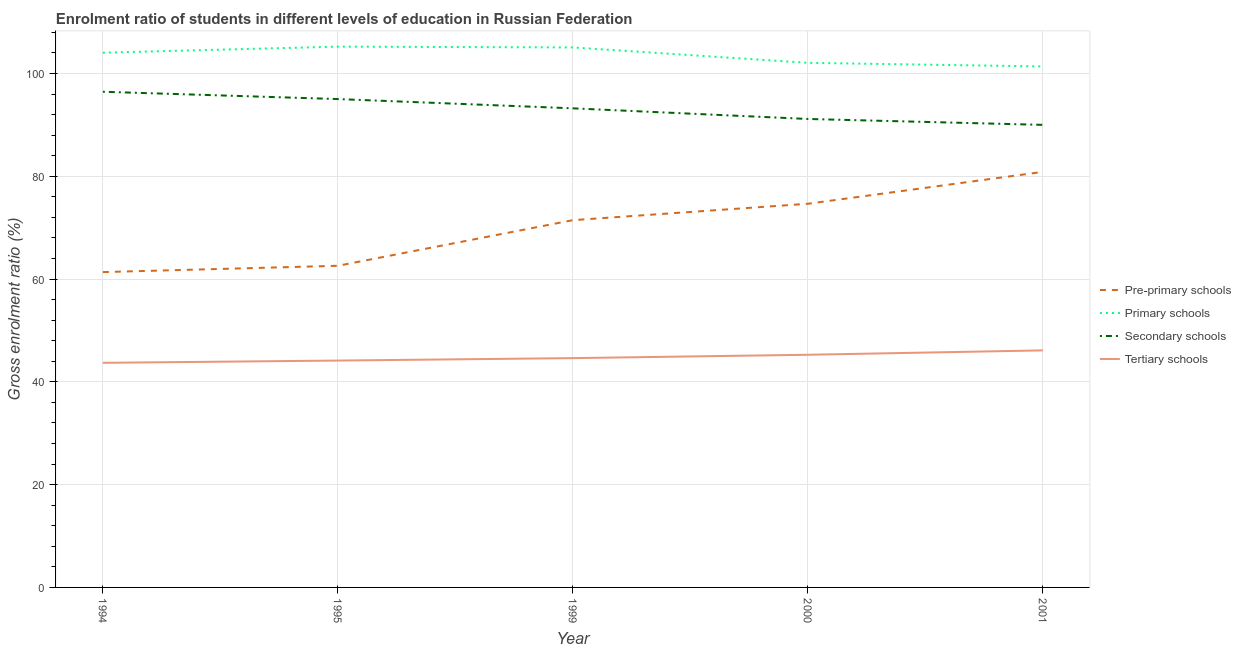Is the number of lines equal to the number of legend labels?
Provide a short and direct response. Yes. What is the gross enrolment ratio in secondary schools in 1994?
Offer a terse response. 96.45. Across all years, what is the maximum gross enrolment ratio in tertiary schools?
Your response must be concise. 46.13. Across all years, what is the minimum gross enrolment ratio in secondary schools?
Ensure brevity in your answer.  90.01. In which year was the gross enrolment ratio in tertiary schools maximum?
Your answer should be very brief. 2001. In which year was the gross enrolment ratio in primary schools minimum?
Provide a short and direct response. 2001. What is the total gross enrolment ratio in tertiary schools in the graph?
Make the answer very short. 223.87. What is the difference between the gross enrolment ratio in primary schools in 1995 and that in 1999?
Your response must be concise. 0.16. What is the difference between the gross enrolment ratio in tertiary schools in 1999 and the gross enrolment ratio in pre-primary schools in 1994?
Provide a succinct answer. -16.74. What is the average gross enrolment ratio in pre-primary schools per year?
Make the answer very short. 70.19. In the year 1999, what is the difference between the gross enrolment ratio in pre-primary schools and gross enrolment ratio in primary schools?
Your response must be concise. -33.61. What is the ratio of the gross enrolment ratio in pre-primary schools in 1995 to that in 2001?
Your answer should be very brief. 0.77. Is the gross enrolment ratio in tertiary schools in 1999 less than that in 2000?
Provide a short and direct response. Yes. Is the difference between the gross enrolment ratio in tertiary schools in 1995 and 1999 greater than the difference between the gross enrolment ratio in pre-primary schools in 1995 and 1999?
Keep it short and to the point. Yes. What is the difference between the highest and the second highest gross enrolment ratio in tertiary schools?
Provide a short and direct response. 0.86. What is the difference between the highest and the lowest gross enrolment ratio in primary schools?
Your answer should be very brief. 3.86. Is the sum of the gross enrolment ratio in tertiary schools in 1994 and 2001 greater than the maximum gross enrolment ratio in primary schools across all years?
Your response must be concise. No. Is it the case that in every year, the sum of the gross enrolment ratio in tertiary schools and gross enrolment ratio in pre-primary schools is greater than the sum of gross enrolment ratio in primary schools and gross enrolment ratio in secondary schools?
Ensure brevity in your answer.  No. Does the gross enrolment ratio in tertiary schools monotonically increase over the years?
Make the answer very short. Yes. Is the gross enrolment ratio in primary schools strictly greater than the gross enrolment ratio in tertiary schools over the years?
Provide a short and direct response. Yes. Is the gross enrolment ratio in pre-primary schools strictly less than the gross enrolment ratio in tertiary schools over the years?
Give a very brief answer. No. How many years are there in the graph?
Offer a very short reply. 5. What is the difference between two consecutive major ticks on the Y-axis?
Make the answer very short. 20. What is the title of the graph?
Your response must be concise. Enrolment ratio of students in different levels of education in Russian Federation. What is the label or title of the Y-axis?
Give a very brief answer. Gross enrolment ratio (%). What is the Gross enrolment ratio (%) in Pre-primary schools in 1994?
Offer a very short reply. 61.36. What is the Gross enrolment ratio (%) in Primary schools in 1994?
Ensure brevity in your answer.  104.05. What is the Gross enrolment ratio (%) of Secondary schools in 1994?
Ensure brevity in your answer.  96.45. What is the Gross enrolment ratio (%) in Tertiary schools in 1994?
Your answer should be compact. 43.7. What is the Gross enrolment ratio (%) of Pre-primary schools in 1995?
Offer a very short reply. 62.59. What is the Gross enrolment ratio (%) in Primary schools in 1995?
Provide a short and direct response. 105.23. What is the Gross enrolment ratio (%) in Secondary schools in 1995?
Provide a short and direct response. 95.03. What is the Gross enrolment ratio (%) in Tertiary schools in 1995?
Provide a succinct answer. 44.15. What is the Gross enrolment ratio (%) of Pre-primary schools in 1999?
Give a very brief answer. 71.46. What is the Gross enrolment ratio (%) in Primary schools in 1999?
Keep it short and to the point. 105.07. What is the Gross enrolment ratio (%) of Secondary schools in 1999?
Your response must be concise. 93.23. What is the Gross enrolment ratio (%) of Tertiary schools in 1999?
Your answer should be compact. 44.62. What is the Gross enrolment ratio (%) in Pre-primary schools in 2000?
Provide a succinct answer. 74.66. What is the Gross enrolment ratio (%) of Primary schools in 2000?
Your answer should be very brief. 102.08. What is the Gross enrolment ratio (%) in Secondary schools in 2000?
Provide a short and direct response. 91.15. What is the Gross enrolment ratio (%) of Tertiary schools in 2000?
Your answer should be compact. 45.27. What is the Gross enrolment ratio (%) of Pre-primary schools in 2001?
Offer a very short reply. 80.86. What is the Gross enrolment ratio (%) of Primary schools in 2001?
Offer a very short reply. 101.37. What is the Gross enrolment ratio (%) of Secondary schools in 2001?
Your answer should be compact. 90.01. What is the Gross enrolment ratio (%) of Tertiary schools in 2001?
Keep it short and to the point. 46.13. Across all years, what is the maximum Gross enrolment ratio (%) in Pre-primary schools?
Make the answer very short. 80.86. Across all years, what is the maximum Gross enrolment ratio (%) of Primary schools?
Provide a short and direct response. 105.23. Across all years, what is the maximum Gross enrolment ratio (%) in Secondary schools?
Provide a short and direct response. 96.45. Across all years, what is the maximum Gross enrolment ratio (%) in Tertiary schools?
Your answer should be very brief. 46.13. Across all years, what is the minimum Gross enrolment ratio (%) of Pre-primary schools?
Your answer should be compact. 61.36. Across all years, what is the minimum Gross enrolment ratio (%) in Primary schools?
Your answer should be very brief. 101.37. Across all years, what is the minimum Gross enrolment ratio (%) in Secondary schools?
Ensure brevity in your answer.  90.01. Across all years, what is the minimum Gross enrolment ratio (%) of Tertiary schools?
Provide a short and direct response. 43.7. What is the total Gross enrolment ratio (%) of Pre-primary schools in the graph?
Ensure brevity in your answer.  350.93. What is the total Gross enrolment ratio (%) of Primary schools in the graph?
Keep it short and to the point. 517.81. What is the total Gross enrolment ratio (%) of Secondary schools in the graph?
Your answer should be very brief. 465.87. What is the total Gross enrolment ratio (%) of Tertiary schools in the graph?
Your answer should be very brief. 223.87. What is the difference between the Gross enrolment ratio (%) of Pre-primary schools in 1994 and that in 1995?
Ensure brevity in your answer.  -1.23. What is the difference between the Gross enrolment ratio (%) in Primary schools in 1994 and that in 1995?
Offer a terse response. -1.18. What is the difference between the Gross enrolment ratio (%) of Secondary schools in 1994 and that in 1995?
Provide a succinct answer. 1.42. What is the difference between the Gross enrolment ratio (%) of Tertiary schools in 1994 and that in 1995?
Give a very brief answer. -0.44. What is the difference between the Gross enrolment ratio (%) of Pre-primary schools in 1994 and that in 1999?
Make the answer very short. -10.1. What is the difference between the Gross enrolment ratio (%) of Primary schools in 1994 and that in 1999?
Keep it short and to the point. -1.02. What is the difference between the Gross enrolment ratio (%) in Secondary schools in 1994 and that in 1999?
Your answer should be very brief. 3.23. What is the difference between the Gross enrolment ratio (%) of Tertiary schools in 1994 and that in 1999?
Offer a terse response. -0.92. What is the difference between the Gross enrolment ratio (%) in Pre-primary schools in 1994 and that in 2000?
Provide a succinct answer. -13.3. What is the difference between the Gross enrolment ratio (%) of Primary schools in 1994 and that in 2000?
Ensure brevity in your answer.  1.97. What is the difference between the Gross enrolment ratio (%) in Secondary schools in 1994 and that in 2000?
Your response must be concise. 5.3. What is the difference between the Gross enrolment ratio (%) in Tertiary schools in 1994 and that in 2000?
Your answer should be very brief. -1.57. What is the difference between the Gross enrolment ratio (%) of Pre-primary schools in 1994 and that in 2001?
Your answer should be very brief. -19.5. What is the difference between the Gross enrolment ratio (%) of Primary schools in 1994 and that in 2001?
Ensure brevity in your answer.  2.68. What is the difference between the Gross enrolment ratio (%) of Secondary schools in 1994 and that in 2001?
Provide a succinct answer. 6.44. What is the difference between the Gross enrolment ratio (%) of Tertiary schools in 1994 and that in 2001?
Provide a short and direct response. -2.42. What is the difference between the Gross enrolment ratio (%) of Pre-primary schools in 1995 and that in 1999?
Provide a short and direct response. -8.88. What is the difference between the Gross enrolment ratio (%) of Primary schools in 1995 and that in 1999?
Give a very brief answer. 0.16. What is the difference between the Gross enrolment ratio (%) of Secondary schools in 1995 and that in 1999?
Provide a short and direct response. 1.8. What is the difference between the Gross enrolment ratio (%) of Tertiary schools in 1995 and that in 1999?
Provide a short and direct response. -0.47. What is the difference between the Gross enrolment ratio (%) of Pre-primary schools in 1995 and that in 2000?
Your answer should be compact. -12.07. What is the difference between the Gross enrolment ratio (%) in Primary schools in 1995 and that in 2000?
Give a very brief answer. 3.15. What is the difference between the Gross enrolment ratio (%) in Secondary schools in 1995 and that in 2000?
Give a very brief answer. 3.87. What is the difference between the Gross enrolment ratio (%) of Tertiary schools in 1995 and that in 2000?
Your answer should be very brief. -1.13. What is the difference between the Gross enrolment ratio (%) of Pre-primary schools in 1995 and that in 2001?
Provide a short and direct response. -18.28. What is the difference between the Gross enrolment ratio (%) in Primary schools in 1995 and that in 2001?
Provide a short and direct response. 3.86. What is the difference between the Gross enrolment ratio (%) in Secondary schools in 1995 and that in 2001?
Make the answer very short. 5.02. What is the difference between the Gross enrolment ratio (%) of Tertiary schools in 1995 and that in 2001?
Give a very brief answer. -1.98. What is the difference between the Gross enrolment ratio (%) in Pre-primary schools in 1999 and that in 2000?
Provide a short and direct response. -3.19. What is the difference between the Gross enrolment ratio (%) in Primary schools in 1999 and that in 2000?
Offer a terse response. 3. What is the difference between the Gross enrolment ratio (%) in Secondary schools in 1999 and that in 2000?
Your answer should be very brief. 2.07. What is the difference between the Gross enrolment ratio (%) in Tertiary schools in 1999 and that in 2000?
Ensure brevity in your answer.  -0.65. What is the difference between the Gross enrolment ratio (%) in Pre-primary schools in 1999 and that in 2001?
Ensure brevity in your answer.  -9.4. What is the difference between the Gross enrolment ratio (%) in Primary schools in 1999 and that in 2001?
Offer a terse response. 3.7. What is the difference between the Gross enrolment ratio (%) in Secondary schools in 1999 and that in 2001?
Make the answer very short. 3.22. What is the difference between the Gross enrolment ratio (%) of Tertiary schools in 1999 and that in 2001?
Your answer should be compact. -1.51. What is the difference between the Gross enrolment ratio (%) in Pre-primary schools in 2000 and that in 2001?
Provide a succinct answer. -6.21. What is the difference between the Gross enrolment ratio (%) of Primary schools in 2000 and that in 2001?
Your answer should be compact. 0.7. What is the difference between the Gross enrolment ratio (%) of Secondary schools in 2000 and that in 2001?
Your answer should be very brief. 1.15. What is the difference between the Gross enrolment ratio (%) in Tertiary schools in 2000 and that in 2001?
Make the answer very short. -0.86. What is the difference between the Gross enrolment ratio (%) in Pre-primary schools in 1994 and the Gross enrolment ratio (%) in Primary schools in 1995?
Ensure brevity in your answer.  -43.87. What is the difference between the Gross enrolment ratio (%) of Pre-primary schools in 1994 and the Gross enrolment ratio (%) of Secondary schools in 1995?
Offer a terse response. -33.67. What is the difference between the Gross enrolment ratio (%) in Pre-primary schools in 1994 and the Gross enrolment ratio (%) in Tertiary schools in 1995?
Your response must be concise. 17.21. What is the difference between the Gross enrolment ratio (%) of Primary schools in 1994 and the Gross enrolment ratio (%) of Secondary schools in 1995?
Make the answer very short. 9.02. What is the difference between the Gross enrolment ratio (%) in Primary schools in 1994 and the Gross enrolment ratio (%) in Tertiary schools in 1995?
Offer a terse response. 59.91. What is the difference between the Gross enrolment ratio (%) of Secondary schools in 1994 and the Gross enrolment ratio (%) of Tertiary schools in 1995?
Your response must be concise. 52.31. What is the difference between the Gross enrolment ratio (%) in Pre-primary schools in 1994 and the Gross enrolment ratio (%) in Primary schools in 1999?
Make the answer very short. -43.72. What is the difference between the Gross enrolment ratio (%) of Pre-primary schools in 1994 and the Gross enrolment ratio (%) of Secondary schools in 1999?
Give a very brief answer. -31.87. What is the difference between the Gross enrolment ratio (%) in Pre-primary schools in 1994 and the Gross enrolment ratio (%) in Tertiary schools in 1999?
Ensure brevity in your answer.  16.74. What is the difference between the Gross enrolment ratio (%) of Primary schools in 1994 and the Gross enrolment ratio (%) of Secondary schools in 1999?
Provide a short and direct response. 10.82. What is the difference between the Gross enrolment ratio (%) in Primary schools in 1994 and the Gross enrolment ratio (%) in Tertiary schools in 1999?
Provide a succinct answer. 59.43. What is the difference between the Gross enrolment ratio (%) of Secondary schools in 1994 and the Gross enrolment ratio (%) of Tertiary schools in 1999?
Offer a very short reply. 51.83. What is the difference between the Gross enrolment ratio (%) of Pre-primary schools in 1994 and the Gross enrolment ratio (%) of Primary schools in 2000?
Ensure brevity in your answer.  -40.72. What is the difference between the Gross enrolment ratio (%) in Pre-primary schools in 1994 and the Gross enrolment ratio (%) in Secondary schools in 2000?
Your answer should be compact. -29.8. What is the difference between the Gross enrolment ratio (%) of Pre-primary schools in 1994 and the Gross enrolment ratio (%) of Tertiary schools in 2000?
Provide a succinct answer. 16.09. What is the difference between the Gross enrolment ratio (%) in Primary schools in 1994 and the Gross enrolment ratio (%) in Secondary schools in 2000?
Give a very brief answer. 12.9. What is the difference between the Gross enrolment ratio (%) in Primary schools in 1994 and the Gross enrolment ratio (%) in Tertiary schools in 2000?
Offer a terse response. 58.78. What is the difference between the Gross enrolment ratio (%) of Secondary schools in 1994 and the Gross enrolment ratio (%) of Tertiary schools in 2000?
Your answer should be very brief. 51.18. What is the difference between the Gross enrolment ratio (%) of Pre-primary schools in 1994 and the Gross enrolment ratio (%) of Primary schools in 2001?
Offer a terse response. -40.02. What is the difference between the Gross enrolment ratio (%) in Pre-primary schools in 1994 and the Gross enrolment ratio (%) in Secondary schools in 2001?
Your response must be concise. -28.65. What is the difference between the Gross enrolment ratio (%) in Pre-primary schools in 1994 and the Gross enrolment ratio (%) in Tertiary schools in 2001?
Your answer should be very brief. 15.23. What is the difference between the Gross enrolment ratio (%) in Primary schools in 1994 and the Gross enrolment ratio (%) in Secondary schools in 2001?
Your answer should be compact. 14.04. What is the difference between the Gross enrolment ratio (%) in Primary schools in 1994 and the Gross enrolment ratio (%) in Tertiary schools in 2001?
Offer a terse response. 57.92. What is the difference between the Gross enrolment ratio (%) of Secondary schools in 1994 and the Gross enrolment ratio (%) of Tertiary schools in 2001?
Keep it short and to the point. 50.32. What is the difference between the Gross enrolment ratio (%) of Pre-primary schools in 1995 and the Gross enrolment ratio (%) of Primary schools in 1999?
Your answer should be compact. -42.49. What is the difference between the Gross enrolment ratio (%) in Pre-primary schools in 1995 and the Gross enrolment ratio (%) in Secondary schools in 1999?
Make the answer very short. -30.64. What is the difference between the Gross enrolment ratio (%) in Pre-primary schools in 1995 and the Gross enrolment ratio (%) in Tertiary schools in 1999?
Your response must be concise. 17.97. What is the difference between the Gross enrolment ratio (%) in Primary schools in 1995 and the Gross enrolment ratio (%) in Secondary schools in 1999?
Offer a terse response. 12. What is the difference between the Gross enrolment ratio (%) in Primary schools in 1995 and the Gross enrolment ratio (%) in Tertiary schools in 1999?
Offer a terse response. 60.61. What is the difference between the Gross enrolment ratio (%) in Secondary schools in 1995 and the Gross enrolment ratio (%) in Tertiary schools in 1999?
Your answer should be compact. 50.41. What is the difference between the Gross enrolment ratio (%) of Pre-primary schools in 1995 and the Gross enrolment ratio (%) of Primary schools in 2000?
Make the answer very short. -39.49. What is the difference between the Gross enrolment ratio (%) in Pre-primary schools in 1995 and the Gross enrolment ratio (%) in Secondary schools in 2000?
Offer a very short reply. -28.57. What is the difference between the Gross enrolment ratio (%) in Pre-primary schools in 1995 and the Gross enrolment ratio (%) in Tertiary schools in 2000?
Your answer should be compact. 17.32. What is the difference between the Gross enrolment ratio (%) of Primary schools in 1995 and the Gross enrolment ratio (%) of Secondary schools in 2000?
Your answer should be compact. 14.08. What is the difference between the Gross enrolment ratio (%) in Primary schools in 1995 and the Gross enrolment ratio (%) in Tertiary schools in 2000?
Make the answer very short. 59.96. What is the difference between the Gross enrolment ratio (%) in Secondary schools in 1995 and the Gross enrolment ratio (%) in Tertiary schools in 2000?
Offer a terse response. 49.76. What is the difference between the Gross enrolment ratio (%) of Pre-primary schools in 1995 and the Gross enrolment ratio (%) of Primary schools in 2001?
Your response must be concise. -38.79. What is the difference between the Gross enrolment ratio (%) of Pre-primary schools in 1995 and the Gross enrolment ratio (%) of Secondary schools in 2001?
Offer a very short reply. -27.42. What is the difference between the Gross enrolment ratio (%) in Pre-primary schools in 1995 and the Gross enrolment ratio (%) in Tertiary schools in 2001?
Make the answer very short. 16.46. What is the difference between the Gross enrolment ratio (%) in Primary schools in 1995 and the Gross enrolment ratio (%) in Secondary schools in 2001?
Offer a very short reply. 15.22. What is the difference between the Gross enrolment ratio (%) of Primary schools in 1995 and the Gross enrolment ratio (%) of Tertiary schools in 2001?
Your answer should be compact. 59.1. What is the difference between the Gross enrolment ratio (%) of Secondary schools in 1995 and the Gross enrolment ratio (%) of Tertiary schools in 2001?
Provide a short and direct response. 48.9. What is the difference between the Gross enrolment ratio (%) of Pre-primary schools in 1999 and the Gross enrolment ratio (%) of Primary schools in 2000?
Your response must be concise. -30.61. What is the difference between the Gross enrolment ratio (%) of Pre-primary schools in 1999 and the Gross enrolment ratio (%) of Secondary schools in 2000?
Make the answer very short. -19.69. What is the difference between the Gross enrolment ratio (%) in Pre-primary schools in 1999 and the Gross enrolment ratio (%) in Tertiary schools in 2000?
Provide a short and direct response. 26.19. What is the difference between the Gross enrolment ratio (%) of Primary schools in 1999 and the Gross enrolment ratio (%) of Secondary schools in 2000?
Your response must be concise. 13.92. What is the difference between the Gross enrolment ratio (%) of Primary schools in 1999 and the Gross enrolment ratio (%) of Tertiary schools in 2000?
Provide a short and direct response. 59.8. What is the difference between the Gross enrolment ratio (%) of Secondary schools in 1999 and the Gross enrolment ratio (%) of Tertiary schools in 2000?
Offer a terse response. 47.95. What is the difference between the Gross enrolment ratio (%) in Pre-primary schools in 1999 and the Gross enrolment ratio (%) in Primary schools in 2001?
Provide a succinct answer. -29.91. What is the difference between the Gross enrolment ratio (%) in Pre-primary schools in 1999 and the Gross enrolment ratio (%) in Secondary schools in 2001?
Your answer should be very brief. -18.54. What is the difference between the Gross enrolment ratio (%) in Pre-primary schools in 1999 and the Gross enrolment ratio (%) in Tertiary schools in 2001?
Offer a terse response. 25.34. What is the difference between the Gross enrolment ratio (%) of Primary schools in 1999 and the Gross enrolment ratio (%) of Secondary schools in 2001?
Your response must be concise. 15.07. What is the difference between the Gross enrolment ratio (%) in Primary schools in 1999 and the Gross enrolment ratio (%) in Tertiary schools in 2001?
Give a very brief answer. 58.95. What is the difference between the Gross enrolment ratio (%) in Secondary schools in 1999 and the Gross enrolment ratio (%) in Tertiary schools in 2001?
Keep it short and to the point. 47.1. What is the difference between the Gross enrolment ratio (%) in Pre-primary schools in 2000 and the Gross enrolment ratio (%) in Primary schools in 2001?
Your answer should be very brief. -26.72. What is the difference between the Gross enrolment ratio (%) of Pre-primary schools in 2000 and the Gross enrolment ratio (%) of Secondary schools in 2001?
Provide a short and direct response. -15.35. What is the difference between the Gross enrolment ratio (%) of Pre-primary schools in 2000 and the Gross enrolment ratio (%) of Tertiary schools in 2001?
Your response must be concise. 28.53. What is the difference between the Gross enrolment ratio (%) in Primary schools in 2000 and the Gross enrolment ratio (%) in Secondary schools in 2001?
Keep it short and to the point. 12.07. What is the difference between the Gross enrolment ratio (%) in Primary schools in 2000 and the Gross enrolment ratio (%) in Tertiary schools in 2001?
Provide a succinct answer. 55.95. What is the difference between the Gross enrolment ratio (%) in Secondary schools in 2000 and the Gross enrolment ratio (%) in Tertiary schools in 2001?
Your response must be concise. 45.03. What is the average Gross enrolment ratio (%) in Pre-primary schools per year?
Your answer should be compact. 70.19. What is the average Gross enrolment ratio (%) of Primary schools per year?
Offer a very short reply. 103.56. What is the average Gross enrolment ratio (%) in Secondary schools per year?
Offer a very short reply. 93.17. What is the average Gross enrolment ratio (%) in Tertiary schools per year?
Keep it short and to the point. 44.77. In the year 1994, what is the difference between the Gross enrolment ratio (%) of Pre-primary schools and Gross enrolment ratio (%) of Primary schools?
Offer a very short reply. -42.69. In the year 1994, what is the difference between the Gross enrolment ratio (%) in Pre-primary schools and Gross enrolment ratio (%) in Secondary schools?
Provide a short and direct response. -35.09. In the year 1994, what is the difference between the Gross enrolment ratio (%) of Pre-primary schools and Gross enrolment ratio (%) of Tertiary schools?
Your answer should be compact. 17.66. In the year 1994, what is the difference between the Gross enrolment ratio (%) of Primary schools and Gross enrolment ratio (%) of Secondary schools?
Offer a very short reply. 7.6. In the year 1994, what is the difference between the Gross enrolment ratio (%) in Primary schools and Gross enrolment ratio (%) in Tertiary schools?
Keep it short and to the point. 60.35. In the year 1994, what is the difference between the Gross enrolment ratio (%) of Secondary schools and Gross enrolment ratio (%) of Tertiary schools?
Your answer should be compact. 52.75. In the year 1995, what is the difference between the Gross enrolment ratio (%) in Pre-primary schools and Gross enrolment ratio (%) in Primary schools?
Your response must be concise. -42.64. In the year 1995, what is the difference between the Gross enrolment ratio (%) of Pre-primary schools and Gross enrolment ratio (%) of Secondary schools?
Your answer should be compact. -32.44. In the year 1995, what is the difference between the Gross enrolment ratio (%) of Pre-primary schools and Gross enrolment ratio (%) of Tertiary schools?
Your answer should be compact. 18.44. In the year 1995, what is the difference between the Gross enrolment ratio (%) of Primary schools and Gross enrolment ratio (%) of Secondary schools?
Your answer should be compact. 10.2. In the year 1995, what is the difference between the Gross enrolment ratio (%) in Primary schools and Gross enrolment ratio (%) in Tertiary schools?
Ensure brevity in your answer.  61.09. In the year 1995, what is the difference between the Gross enrolment ratio (%) of Secondary schools and Gross enrolment ratio (%) of Tertiary schools?
Offer a terse response. 50.88. In the year 1999, what is the difference between the Gross enrolment ratio (%) of Pre-primary schools and Gross enrolment ratio (%) of Primary schools?
Keep it short and to the point. -33.61. In the year 1999, what is the difference between the Gross enrolment ratio (%) in Pre-primary schools and Gross enrolment ratio (%) in Secondary schools?
Offer a terse response. -21.76. In the year 1999, what is the difference between the Gross enrolment ratio (%) in Pre-primary schools and Gross enrolment ratio (%) in Tertiary schools?
Offer a very short reply. 26.84. In the year 1999, what is the difference between the Gross enrolment ratio (%) in Primary schools and Gross enrolment ratio (%) in Secondary schools?
Your answer should be very brief. 11.85. In the year 1999, what is the difference between the Gross enrolment ratio (%) in Primary schools and Gross enrolment ratio (%) in Tertiary schools?
Ensure brevity in your answer.  60.45. In the year 1999, what is the difference between the Gross enrolment ratio (%) in Secondary schools and Gross enrolment ratio (%) in Tertiary schools?
Keep it short and to the point. 48.61. In the year 2000, what is the difference between the Gross enrolment ratio (%) in Pre-primary schools and Gross enrolment ratio (%) in Primary schools?
Provide a succinct answer. -27.42. In the year 2000, what is the difference between the Gross enrolment ratio (%) of Pre-primary schools and Gross enrolment ratio (%) of Secondary schools?
Your answer should be very brief. -16.5. In the year 2000, what is the difference between the Gross enrolment ratio (%) in Pre-primary schools and Gross enrolment ratio (%) in Tertiary schools?
Offer a very short reply. 29.39. In the year 2000, what is the difference between the Gross enrolment ratio (%) in Primary schools and Gross enrolment ratio (%) in Secondary schools?
Offer a very short reply. 10.92. In the year 2000, what is the difference between the Gross enrolment ratio (%) of Primary schools and Gross enrolment ratio (%) of Tertiary schools?
Give a very brief answer. 56.81. In the year 2000, what is the difference between the Gross enrolment ratio (%) of Secondary schools and Gross enrolment ratio (%) of Tertiary schools?
Provide a short and direct response. 45.88. In the year 2001, what is the difference between the Gross enrolment ratio (%) in Pre-primary schools and Gross enrolment ratio (%) in Primary schools?
Ensure brevity in your answer.  -20.51. In the year 2001, what is the difference between the Gross enrolment ratio (%) in Pre-primary schools and Gross enrolment ratio (%) in Secondary schools?
Your response must be concise. -9.14. In the year 2001, what is the difference between the Gross enrolment ratio (%) in Pre-primary schools and Gross enrolment ratio (%) in Tertiary schools?
Your answer should be very brief. 34.74. In the year 2001, what is the difference between the Gross enrolment ratio (%) of Primary schools and Gross enrolment ratio (%) of Secondary schools?
Provide a succinct answer. 11.37. In the year 2001, what is the difference between the Gross enrolment ratio (%) of Primary schools and Gross enrolment ratio (%) of Tertiary schools?
Your answer should be compact. 55.25. In the year 2001, what is the difference between the Gross enrolment ratio (%) in Secondary schools and Gross enrolment ratio (%) in Tertiary schools?
Your response must be concise. 43.88. What is the ratio of the Gross enrolment ratio (%) in Pre-primary schools in 1994 to that in 1995?
Make the answer very short. 0.98. What is the ratio of the Gross enrolment ratio (%) of Primary schools in 1994 to that in 1995?
Give a very brief answer. 0.99. What is the ratio of the Gross enrolment ratio (%) in Secondary schools in 1994 to that in 1995?
Provide a succinct answer. 1.01. What is the ratio of the Gross enrolment ratio (%) of Pre-primary schools in 1994 to that in 1999?
Ensure brevity in your answer.  0.86. What is the ratio of the Gross enrolment ratio (%) in Primary schools in 1994 to that in 1999?
Ensure brevity in your answer.  0.99. What is the ratio of the Gross enrolment ratio (%) in Secondary schools in 1994 to that in 1999?
Offer a very short reply. 1.03. What is the ratio of the Gross enrolment ratio (%) of Tertiary schools in 1994 to that in 1999?
Keep it short and to the point. 0.98. What is the ratio of the Gross enrolment ratio (%) in Pre-primary schools in 1994 to that in 2000?
Offer a very short reply. 0.82. What is the ratio of the Gross enrolment ratio (%) in Primary schools in 1994 to that in 2000?
Offer a very short reply. 1.02. What is the ratio of the Gross enrolment ratio (%) in Secondary schools in 1994 to that in 2000?
Make the answer very short. 1.06. What is the ratio of the Gross enrolment ratio (%) of Tertiary schools in 1994 to that in 2000?
Offer a very short reply. 0.97. What is the ratio of the Gross enrolment ratio (%) in Pre-primary schools in 1994 to that in 2001?
Give a very brief answer. 0.76. What is the ratio of the Gross enrolment ratio (%) in Primary schools in 1994 to that in 2001?
Give a very brief answer. 1.03. What is the ratio of the Gross enrolment ratio (%) of Secondary schools in 1994 to that in 2001?
Your answer should be compact. 1.07. What is the ratio of the Gross enrolment ratio (%) of Tertiary schools in 1994 to that in 2001?
Make the answer very short. 0.95. What is the ratio of the Gross enrolment ratio (%) in Pre-primary schools in 1995 to that in 1999?
Provide a succinct answer. 0.88. What is the ratio of the Gross enrolment ratio (%) in Primary schools in 1995 to that in 1999?
Keep it short and to the point. 1. What is the ratio of the Gross enrolment ratio (%) of Secondary schools in 1995 to that in 1999?
Your answer should be very brief. 1.02. What is the ratio of the Gross enrolment ratio (%) of Pre-primary schools in 1995 to that in 2000?
Provide a succinct answer. 0.84. What is the ratio of the Gross enrolment ratio (%) in Primary schools in 1995 to that in 2000?
Provide a short and direct response. 1.03. What is the ratio of the Gross enrolment ratio (%) of Secondary schools in 1995 to that in 2000?
Provide a short and direct response. 1.04. What is the ratio of the Gross enrolment ratio (%) of Tertiary schools in 1995 to that in 2000?
Offer a terse response. 0.98. What is the ratio of the Gross enrolment ratio (%) in Pre-primary schools in 1995 to that in 2001?
Make the answer very short. 0.77. What is the ratio of the Gross enrolment ratio (%) in Primary schools in 1995 to that in 2001?
Keep it short and to the point. 1.04. What is the ratio of the Gross enrolment ratio (%) in Secondary schools in 1995 to that in 2001?
Offer a terse response. 1.06. What is the ratio of the Gross enrolment ratio (%) in Tertiary schools in 1995 to that in 2001?
Provide a succinct answer. 0.96. What is the ratio of the Gross enrolment ratio (%) in Pre-primary schools in 1999 to that in 2000?
Ensure brevity in your answer.  0.96. What is the ratio of the Gross enrolment ratio (%) in Primary schools in 1999 to that in 2000?
Give a very brief answer. 1.03. What is the ratio of the Gross enrolment ratio (%) in Secondary schools in 1999 to that in 2000?
Your answer should be very brief. 1.02. What is the ratio of the Gross enrolment ratio (%) in Tertiary schools in 1999 to that in 2000?
Ensure brevity in your answer.  0.99. What is the ratio of the Gross enrolment ratio (%) in Pre-primary schools in 1999 to that in 2001?
Give a very brief answer. 0.88. What is the ratio of the Gross enrolment ratio (%) of Primary schools in 1999 to that in 2001?
Give a very brief answer. 1.04. What is the ratio of the Gross enrolment ratio (%) in Secondary schools in 1999 to that in 2001?
Provide a short and direct response. 1.04. What is the ratio of the Gross enrolment ratio (%) of Tertiary schools in 1999 to that in 2001?
Ensure brevity in your answer.  0.97. What is the ratio of the Gross enrolment ratio (%) in Pre-primary schools in 2000 to that in 2001?
Provide a short and direct response. 0.92. What is the ratio of the Gross enrolment ratio (%) of Primary schools in 2000 to that in 2001?
Make the answer very short. 1.01. What is the ratio of the Gross enrolment ratio (%) of Secondary schools in 2000 to that in 2001?
Give a very brief answer. 1.01. What is the ratio of the Gross enrolment ratio (%) of Tertiary schools in 2000 to that in 2001?
Your answer should be compact. 0.98. What is the difference between the highest and the second highest Gross enrolment ratio (%) in Pre-primary schools?
Your answer should be compact. 6.21. What is the difference between the highest and the second highest Gross enrolment ratio (%) of Primary schools?
Give a very brief answer. 0.16. What is the difference between the highest and the second highest Gross enrolment ratio (%) in Secondary schools?
Make the answer very short. 1.42. What is the difference between the highest and the second highest Gross enrolment ratio (%) in Tertiary schools?
Give a very brief answer. 0.86. What is the difference between the highest and the lowest Gross enrolment ratio (%) of Pre-primary schools?
Your response must be concise. 19.5. What is the difference between the highest and the lowest Gross enrolment ratio (%) in Primary schools?
Provide a short and direct response. 3.86. What is the difference between the highest and the lowest Gross enrolment ratio (%) in Secondary schools?
Keep it short and to the point. 6.44. What is the difference between the highest and the lowest Gross enrolment ratio (%) in Tertiary schools?
Provide a short and direct response. 2.42. 